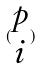Convert formula to latex. <formula><loc_0><loc_0><loc_500><loc_500>( \begin{matrix} p \\ i \end{matrix} )</formula> 